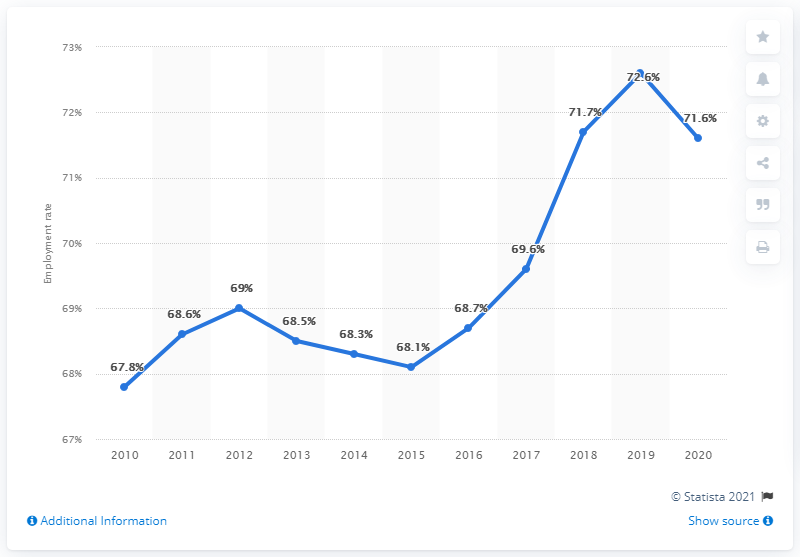Outline some significant characteristics in this image. In 2020, the employment rate was 71.6%. 